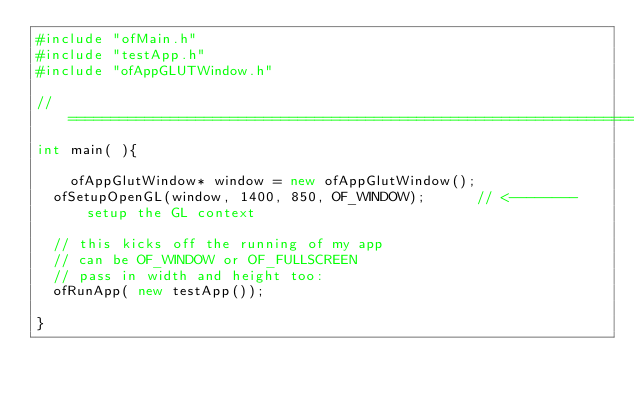Convert code to text. <code><loc_0><loc_0><loc_500><loc_500><_C++_>#include "ofMain.h"
#include "testApp.h"
#include "ofAppGLUTWindow.h"

//========================================================================
int main( ){
    
    ofAppGlutWindow* window = new ofAppGlutWindow();
	ofSetupOpenGL(window, 1400, 850, OF_WINDOW);			// <-------- setup the GL context

	// this kicks off the running of my app
	// can be OF_WINDOW or OF_FULLSCREEN
	// pass in width and height too:
	ofRunApp( new testApp());

}
</code> 